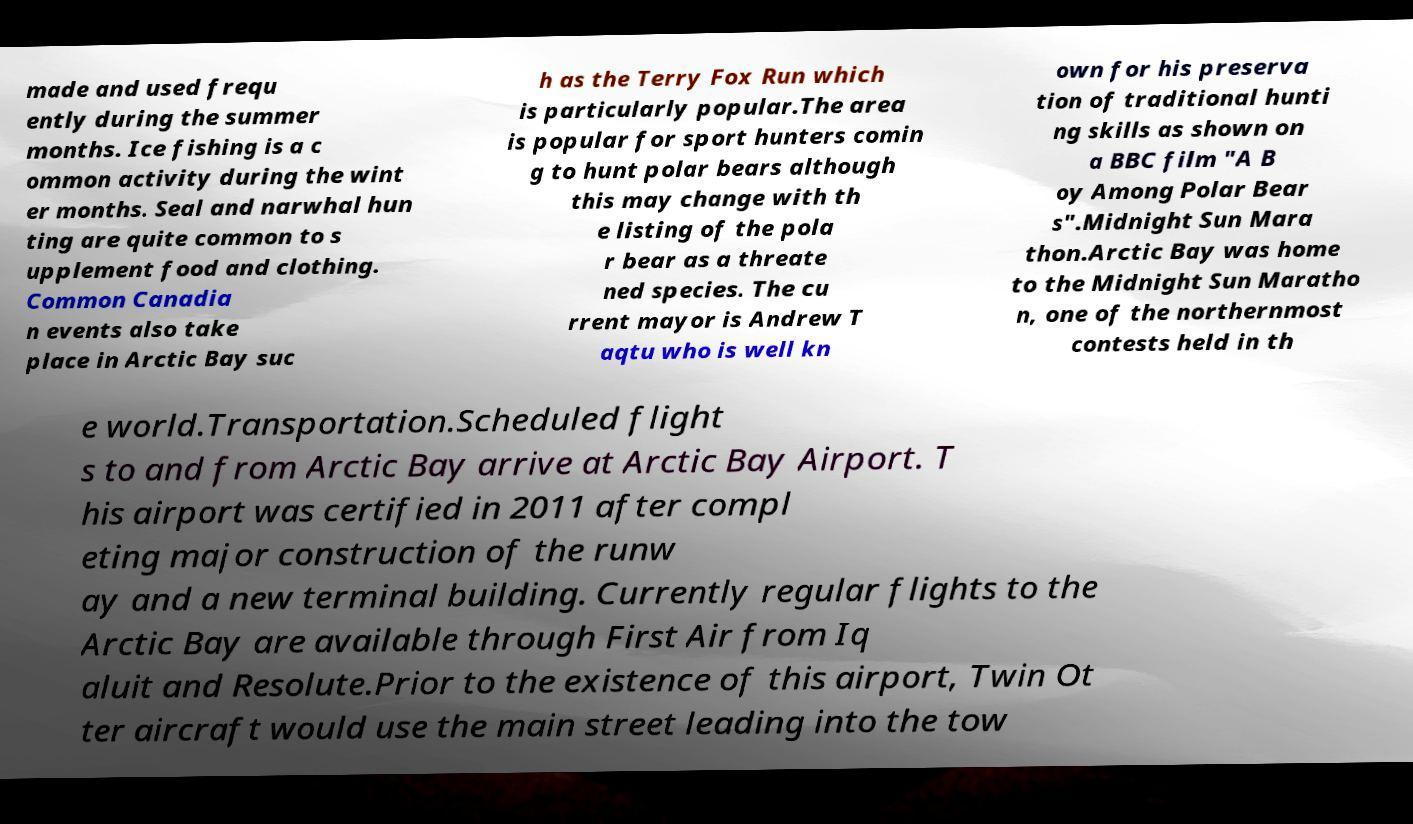For documentation purposes, I need the text within this image transcribed. Could you provide that? made and used frequ ently during the summer months. Ice fishing is a c ommon activity during the wint er months. Seal and narwhal hun ting are quite common to s upplement food and clothing. Common Canadia n events also take place in Arctic Bay suc h as the Terry Fox Run which is particularly popular.The area is popular for sport hunters comin g to hunt polar bears although this may change with th e listing of the pola r bear as a threate ned species. The cu rrent mayor is Andrew T aqtu who is well kn own for his preserva tion of traditional hunti ng skills as shown on a BBC film "A B oy Among Polar Bear s".Midnight Sun Mara thon.Arctic Bay was home to the Midnight Sun Maratho n, one of the northernmost contests held in th e world.Transportation.Scheduled flight s to and from Arctic Bay arrive at Arctic Bay Airport. T his airport was certified in 2011 after compl eting major construction of the runw ay and a new terminal building. Currently regular flights to the Arctic Bay are available through First Air from Iq aluit and Resolute.Prior to the existence of this airport, Twin Ot ter aircraft would use the main street leading into the tow 